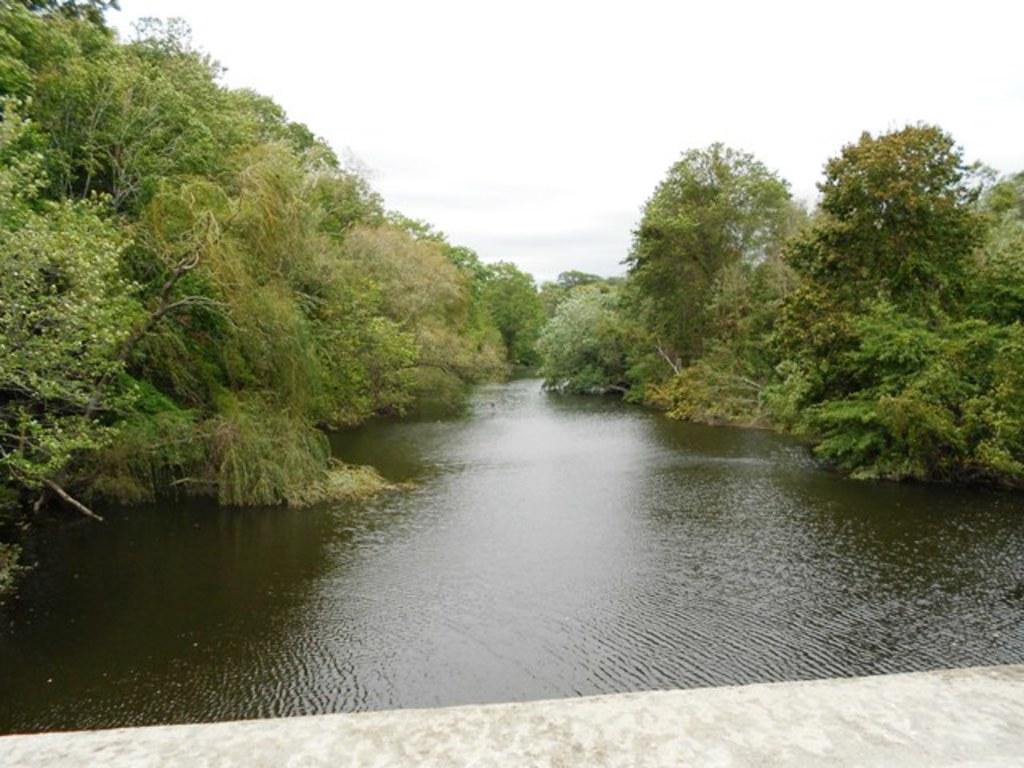What type of natural feature is present in the image? There is a river in the image. How is the water in the river moving? The water in the river is flowing. What type of vegetation can be seen in the image? There are trees with branches and leaves in the image. What type of man-made feature is visible in the image? There is a road visible in the image. What type of meat is being discussed by the trees in the image? There is no discussion or meat present in the image; it features a river, flowing water, trees, and a road. 